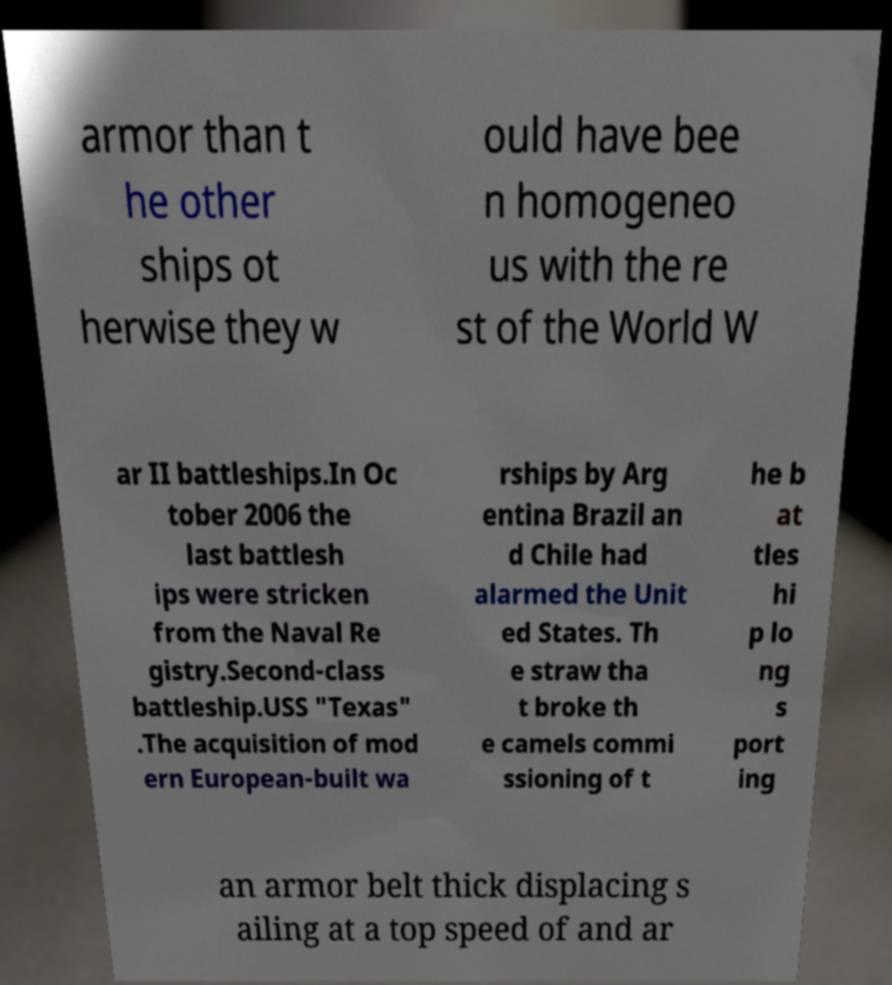There's text embedded in this image that I need extracted. Can you transcribe it verbatim? armor than t he other ships ot herwise they w ould have bee n homogeneo us with the re st of the World W ar II battleships.In Oc tober 2006 the last battlesh ips were stricken from the Naval Re gistry.Second-class battleship.USS "Texas" .The acquisition of mod ern European-built wa rships by Arg entina Brazil an d Chile had alarmed the Unit ed States. Th e straw tha t broke th e camels commi ssioning of t he b at tles hi p lo ng s port ing an armor belt thick displacing s ailing at a top speed of and ar 